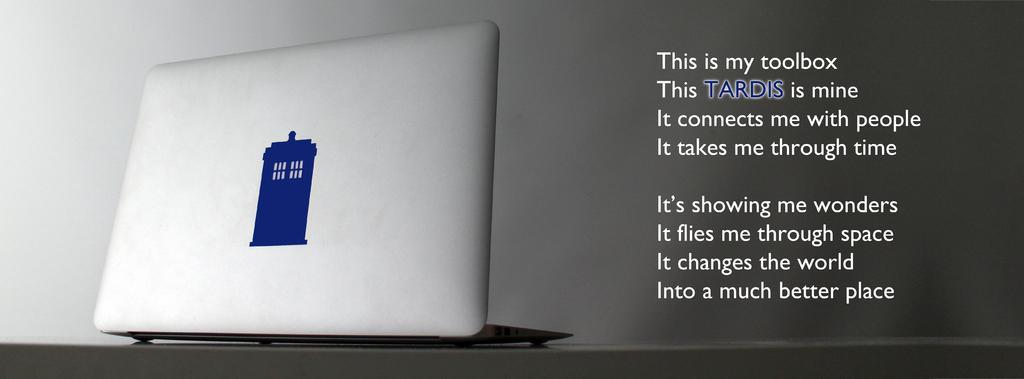How would you summarize this image in a sentence or two? In this image there is a laptop on a surface that looks like a table, there is text, at the background of the image there is the wall. 